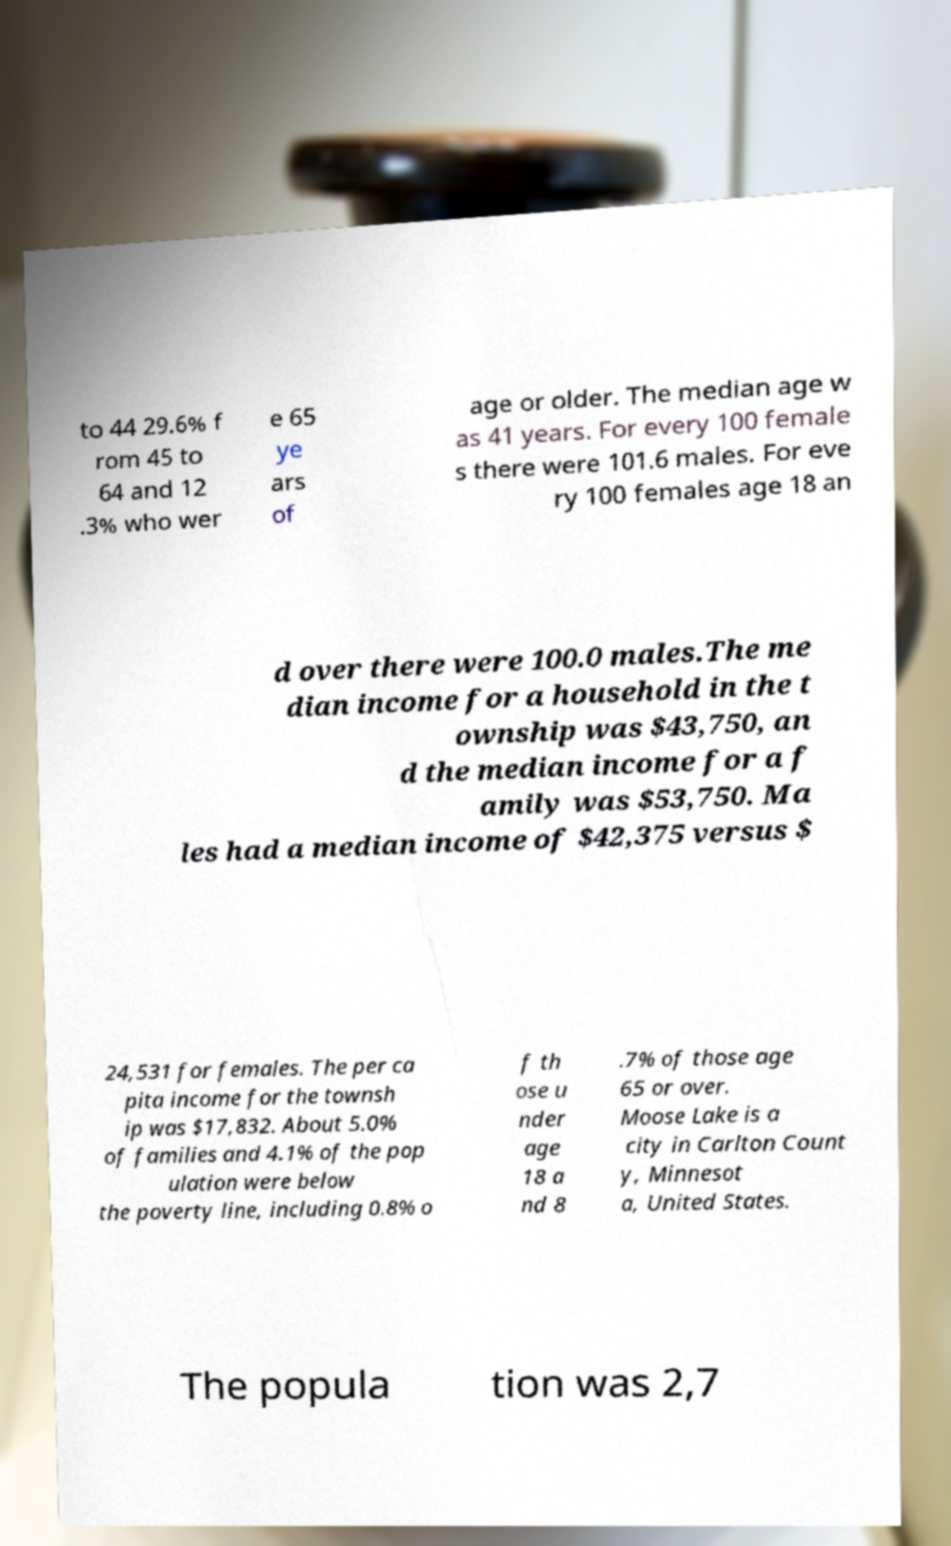What messages or text are displayed in this image? I need them in a readable, typed format. to 44 29.6% f rom 45 to 64 and 12 .3% who wer e 65 ye ars of age or older. The median age w as 41 years. For every 100 female s there were 101.6 males. For eve ry 100 females age 18 an d over there were 100.0 males.The me dian income for a household in the t ownship was $43,750, an d the median income for a f amily was $53,750. Ma les had a median income of $42,375 versus $ 24,531 for females. The per ca pita income for the townsh ip was $17,832. About 5.0% of families and 4.1% of the pop ulation were below the poverty line, including 0.8% o f th ose u nder age 18 a nd 8 .7% of those age 65 or over. Moose Lake is a city in Carlton Count y, Minnesot a, United States. The popula tion was 2,7 